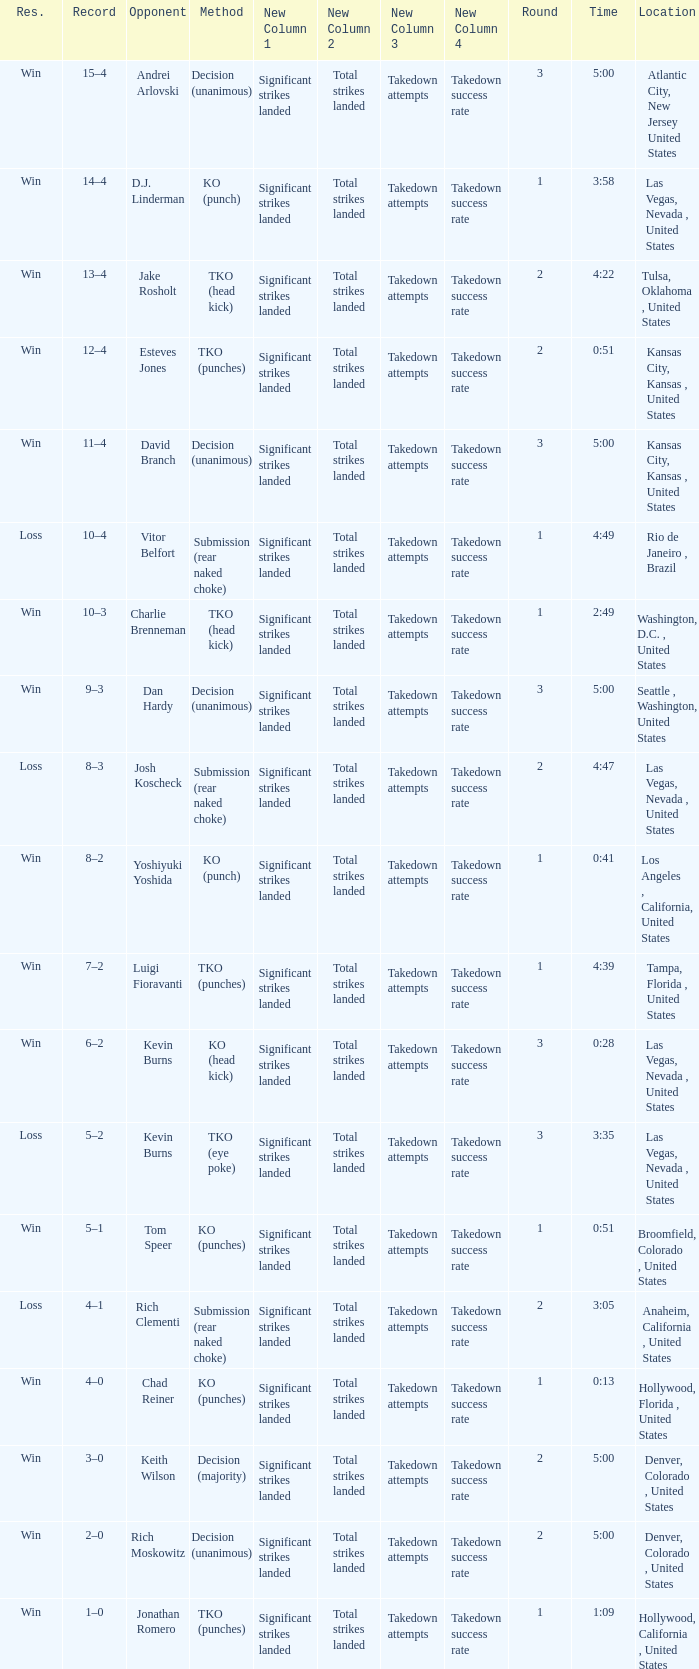What is the highest round number with a time of 4:39? 1.0. 